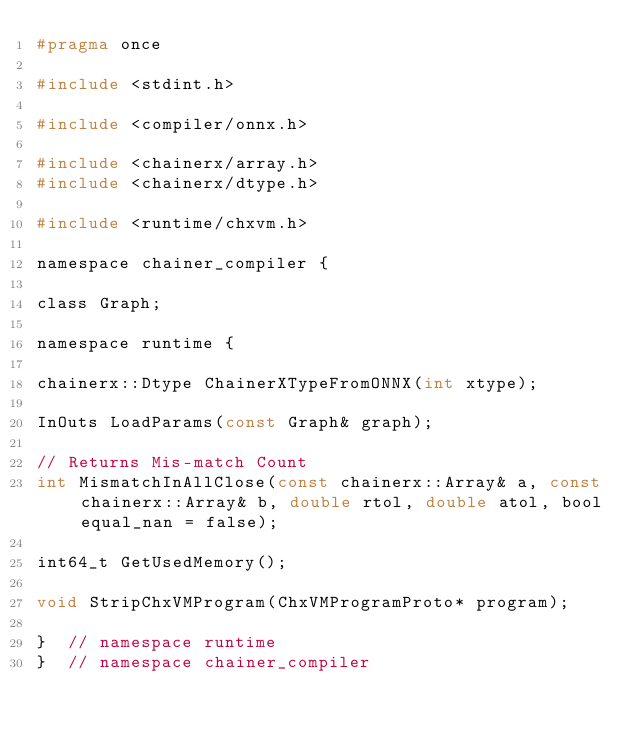<code> <loc_0><loc_0><loc_500><loc_500><_C_>#pragma once

#include <stdint.h>

#include <compiler/onnx.h>

#include <chainerx/array.h>
#include <chainerx/dtype.h>

#include <runtime/chxvm.h>

namespace chainer_compiler {

class Graph;

namespace runtime {

chainerx::Dtype ChainerXTypeFromONNX(int xtype);

InOuts LoadParams(const Graph& graph);

// Returns Mis-match Count
int MismatchInAllClose(const chainerx::Array& a, const chainerx::Array& b, double rtol, double atol, bool equal_nan = false);

int64_t GetUsedMemory();

void StripChxVMProgram(ChxVMProgramProto* program);

}  // namespace runtime
}  // namespace chainer_compiler
</code> 